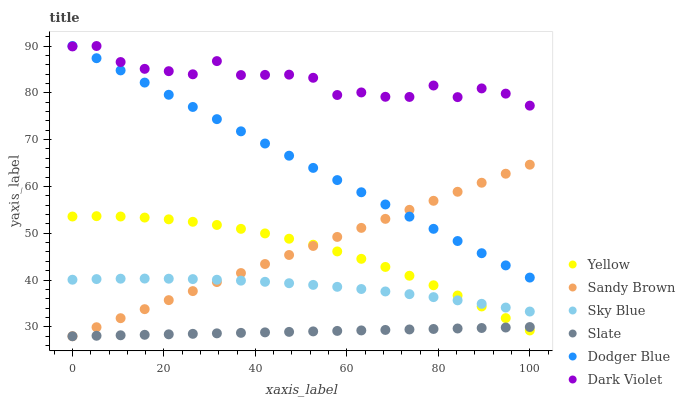Does Slate have the minimum area under the curve?
Answer yes or no. Yes. Does Dark Violet have the maximum area under the curve?
Answer yes or no. Yes. Does Dodger Blue have the minimum area under the curve?
Answer yes or no. No. Does Dodger Blue have the maximum area under the curve?
Answer yes or no. No. Is Slate the smoothest?
Answer yes or no. Yes. Is Dark Violet the roughest?
Answer yes or no. Yes. Is Dodger Blue the smoothest?
Answer yes or no. No. Is Dodger Blue the roughest?
Answer yes or no. No. Does Slate have the lowest value?
Answer yes or no. Yes. Does Dodger Blue have the lowest value?
Answer yes or no. No. Does Dodger Blue have the highest value?
Answer yes or no. Yes. Does Yellow have the highest value?
Answer yes or no. No. Is Yellow less than Dark Violet?
Answer yes or no. Yes. Is Dodger Blue greater than Slate?
Answer yes or no. Yes. Does Slate intersect Sandy Brown?
Answer yes or no. Yes. Is Slate less than Sandy Brown?
Answer yes or no. No. Is Slate greater than Sandy Brown?
Answer yes or no. No. Does Yellow intersect Dark Violet?
Answer yes or no. No. 